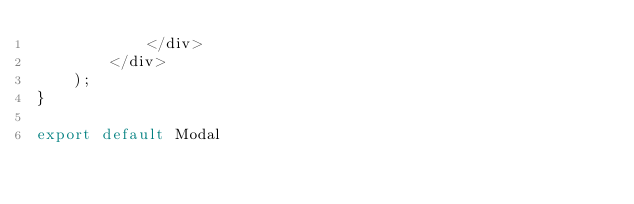<code> <loc_0><loc_0><loc_500><loc_500><_JavaScript_>            </div>
        </div>
    );
}

export default Modal
</code> 